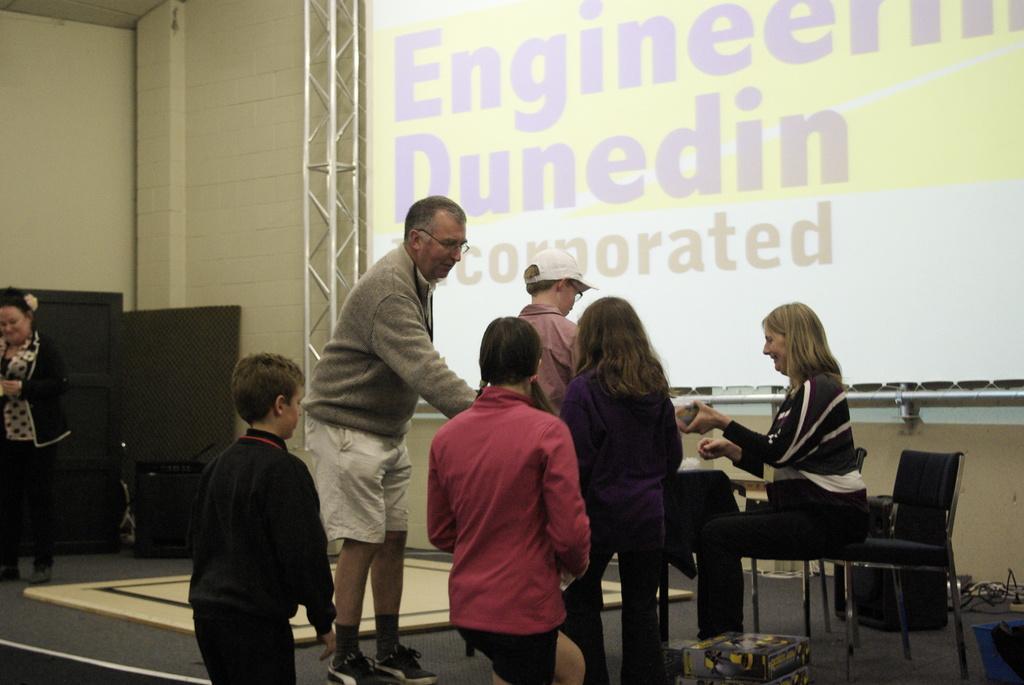In one or two sentences, can you explain what this image depicts? On the stage there are four kids and one man is standing. And to the right side a woman is sitting on a chair. And in the background there is a screen. And to the left corner there is a lady with black jacket and she is standing. 